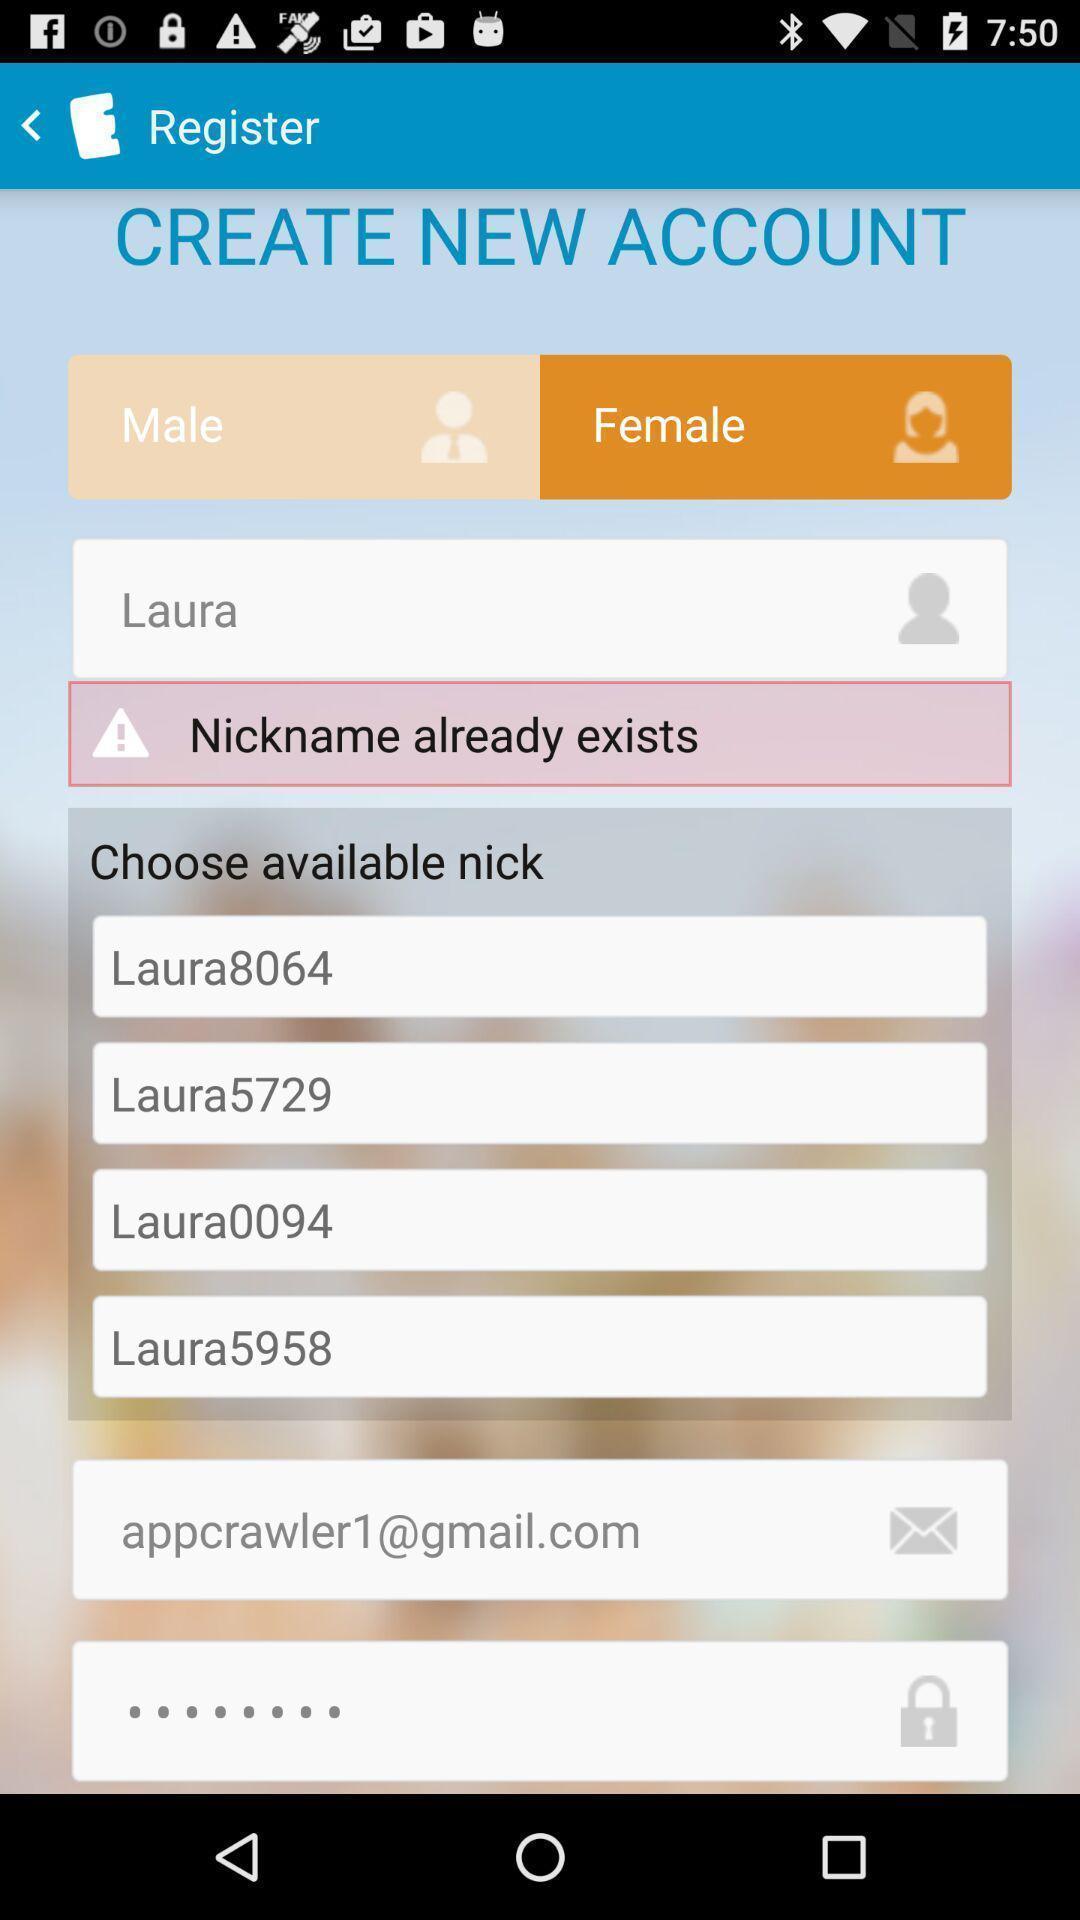Give me a summary of this screen capture. Registration page asking to enter details. 